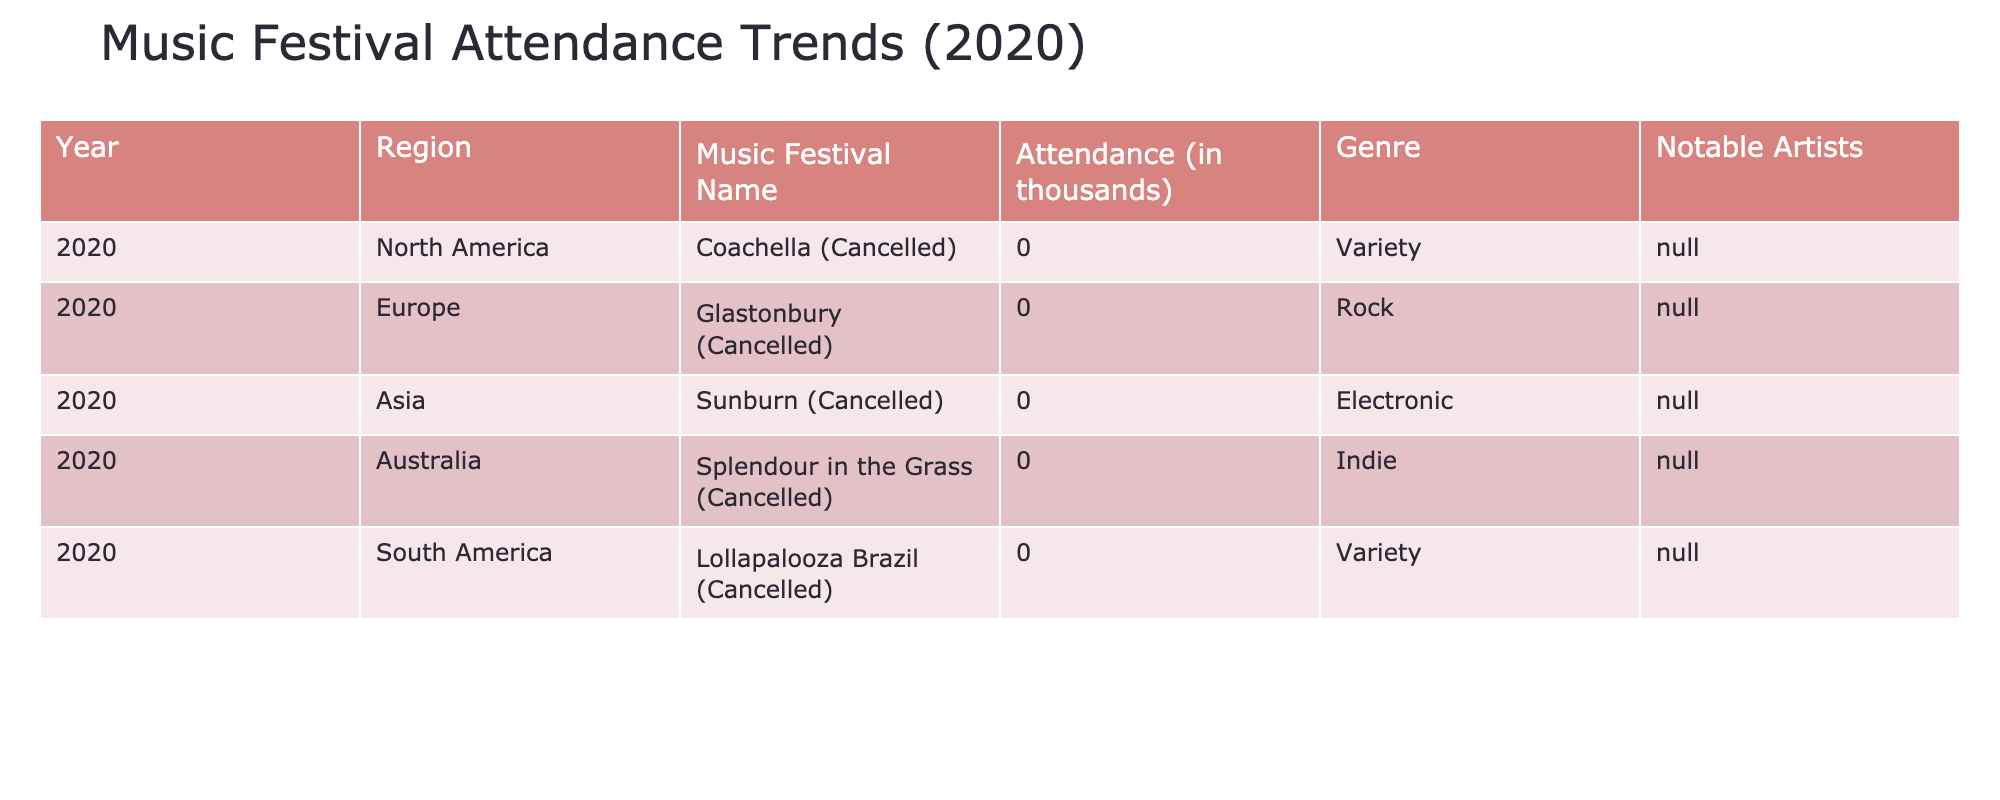What was the total attendance for all festivals in 2020? In 2020, all listed festivals had an attendance of zero due to cancellations. Therefore, the total attendance is 0.
Answer: 0 Which region had festivals that were cancelled in 2020? All regions listed (North America, Europe, Asia, Australia, South America) had festivals that were cancelled in 2020.
Answer: All regions Was there any notable artist listed for the festivals in 2020? The table shows "N/A" for notable artists in all entries for 2020. Therefore, there were no notable artists listed.
Answer: No Which music festival in Australia was cancelled in 2020? The festival listed for Australia was "Splendour in the Grass," and it was cancelled in 2020.
Answer: Splendour in the Grass How many regions had a variety genre festival that was cancelled in 2020? In the table, both North America (Coachella) and South America (Lollapalooza Brazil) had variety genre festivals that were cancelled. Thus, there are 2 regions.
Answer: 2 Is it true that the Glastonbury festival had any attendance in 2020? The table indicates that Glastonbury had an attendance of 0 due to cancellation, so the statement is false.
Answer: False What percentage of festivals listed had an attendance of 0 in 2020? All 5 festivals listed had an attendance of 0. To calculate the percentage: (0/5) * 100 = 0%. Therefore, it is 100% because every festival had zero attendance.
Answer: 100% Which genre had a festival cancelled in every region listed in 2020? The genres listed for the cancelled festivals include Variety, Rock, Electronic, Indie, and Variety. Since five festivals across different genres were cancelled, no genre stands out having a festival cancelled in every region.
Answer: None What was the only notable fact about attendance for all festivals in 2020? The only notable fact is that all festivals reported an attendance of 0, meaning no one attended due to cancellations.
Answer: All had 0 attendance 